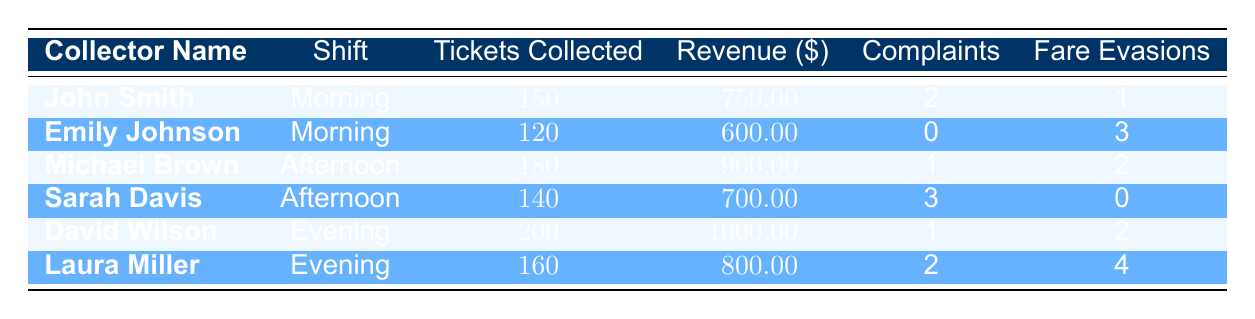What is the highest number of tickets collected in a single shift? The highest number of tickets collected is found in the Evening shift by David Wilson, who collected 200 tickets.
Answer: 200 Which fare collector generated the most revenue? David Wilson generated the most revenue at $1000.00 during the Evening shift.
Answer: David Wilson How many customer complaints were reported by Sarah Davis? Sarah Davis reported 3 customer complaints during her Afternoon shift.
Answer: 3 What is the total number of tickets collected by all fare collectors in the Morning shift? In the Morning shift, John Smith collected 150 tickets and Emily Johnson collected 120 tickets. The total is 150 + 120 = 270 tickets.
Answer: 270 Was there any fare evasion reported by John Smith? Yes, John Smith reported 1 fare evasion during the Morning shift.
Answer: Yes Who had the least revenue generated among the fare collectors? Emily Johnson had the least revenue generated at $600.00 during the Morning shift.
Answer: Emily Johnson What is the average number of customer complaints reported by all fare collectors? The total number of customer complaints is 2 (John Smith) + 0 (Emily Johnson) + 1 (Michael Brown) + 3 (Sarah Davis) + 1 (David Wilson) + 2 (Laura Miller) = 9. There are 6 collectors, so the average is 9 / 6 = 1.5.
Answer: 1.5 Did Emily Johnson collect more tickets than Sarah Davis? No, Emily Johnson collected 120 tickets while Sarah Davis collected 140 tickets in the Afternoon shift.
Answer: No Which shift had the highest total revenue generated? The total revenue for each shift is: Morning ($750.00 + $600.00 = $1350.00), Afternoon ($900.00 + $700.00 = $1600.00), Evening ($1000.00 + $800.00 = $1800.00). The Evening shift had the highest total revenue at $1800.00.
Answer: Evening 